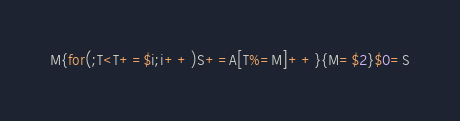Convert code to text. <code><loc_0><loc_0><loc_500><loc_500><_Awk_>M{for(;T<T+=$i;i++)S+=A[T%=M]++}{M=$2}$0=S</code> 